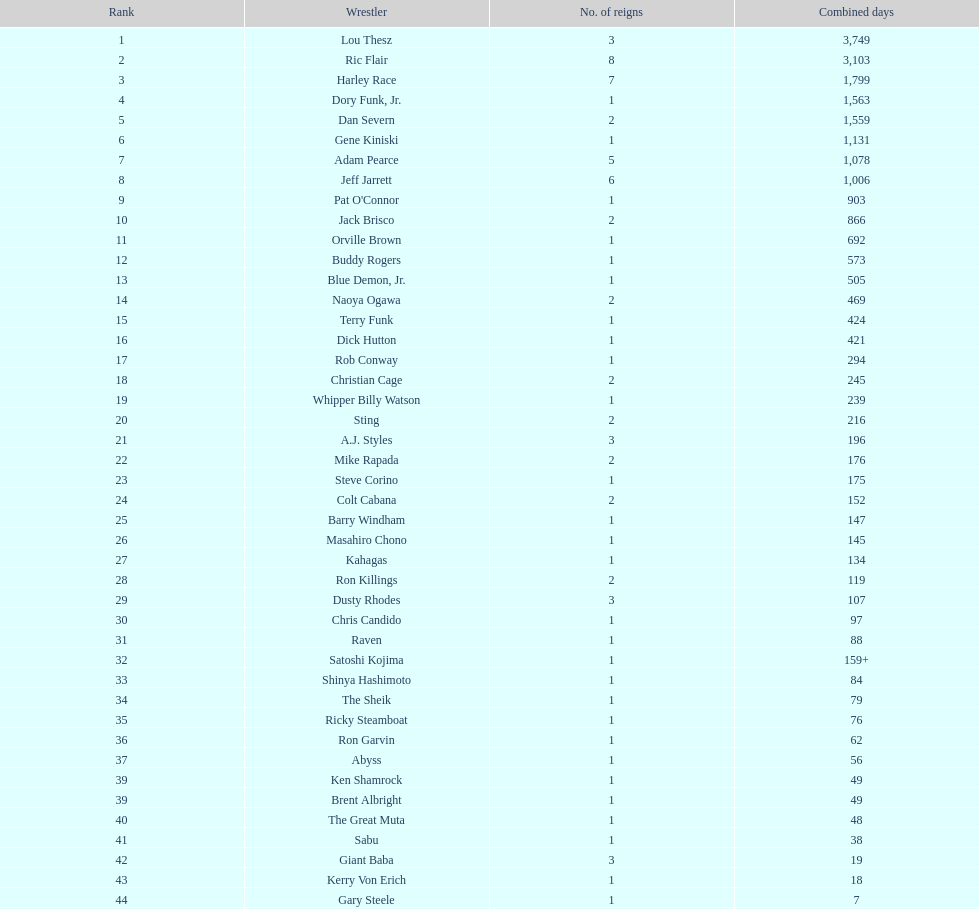Between gene kiniski and ric flair, who held the nwa world heavyweight championship for a longer period? Ric Flair. 